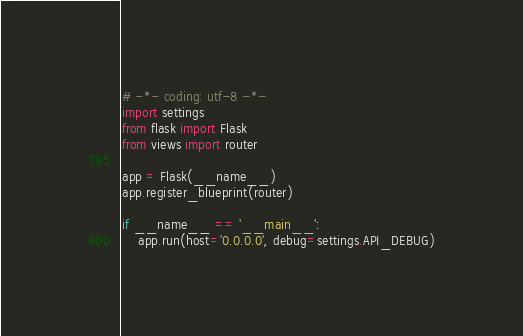Convert code to text. <code><loc_0><loc_0><loc_500><loc_500><_Python_># -*- coding: utf-8 -*-
import settings
from flask import Flask
from views import router

app = Flask(__name__)
app.register_blueprint(router)

if __name__ == '__main__':
    app.run(host='0.0.0.0', debug=settings.API_DEBUG)
</code> 